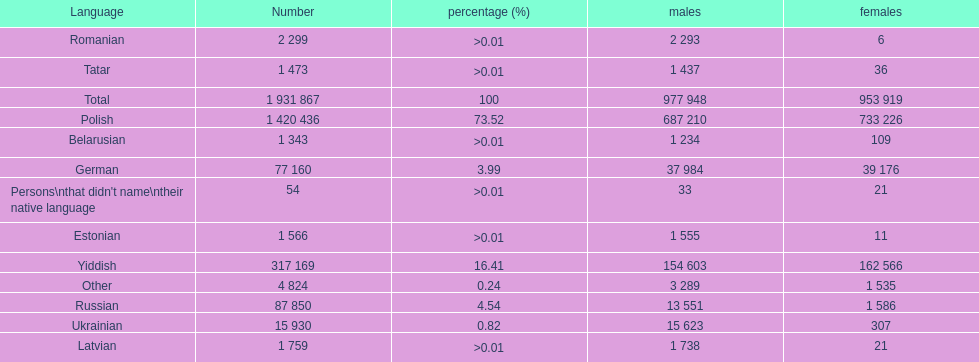The least amount of females Romanian. 